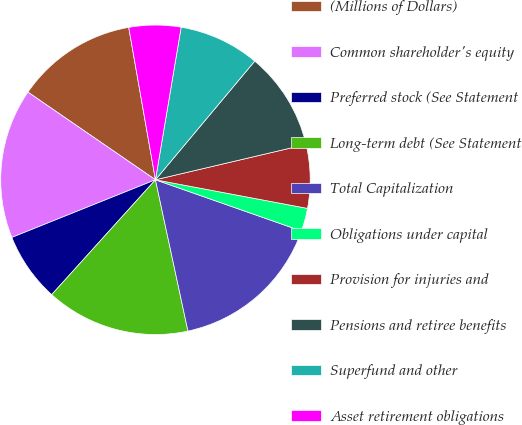<chart> <loc_0><loc_0><loc_500><loc_500><pie_chart><fcel>(Millions of Dollars)<fcel>Common shareholder's equity<fcel>Preferred stock (See Statement<fcel>Long-term debt (See Statement<fcel>Total Capitalization<fcel>Obligations under capital<fcel>Provision for injuries and<fcel>Pensions and retiree benefits<fcel>Superfund and other<fcel>Asset retirement obligations<nl><fcel>12.65%<fcel>15.66%<fcel>7.23%<fcel>15.06%<fcel>16.26%<fcel>2.41%<fcel>6.63%<fcel>10.24%<fcel>8.43%<fcel>5.42%<nl></chart> 